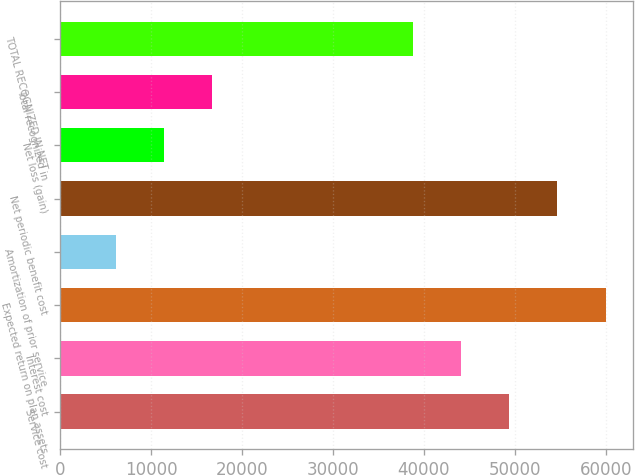Convert chart to OTSL. <chart><loc_0><loc_0><loc_500><loc_500><bar_chart><fcel>Service cost<fcel>Interest cost<fcel>Expected return on plan assets<fcel>Amortization of prior service<fcel>Net periodic benefit cost<fcel>Net loss (gain)<fcel>Total recognized in<fcel>TOTAL RECOGNIZED IN NET<nl><fcel>49357.2<fcel>44049.1<fcel>59973.4<fcel>6095.1<fcel>54665.3<fcel>11403.2<fcel>16711.3<fcel>38741<nl></chart> 